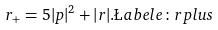Convert formula to latex. <formula><loc_0><loc_0><loc_500><loc_500>r _ { + } = 5 | p | ^ { 2 } + | r | . \L a b e l { e \colon r p l u s }</formula> 